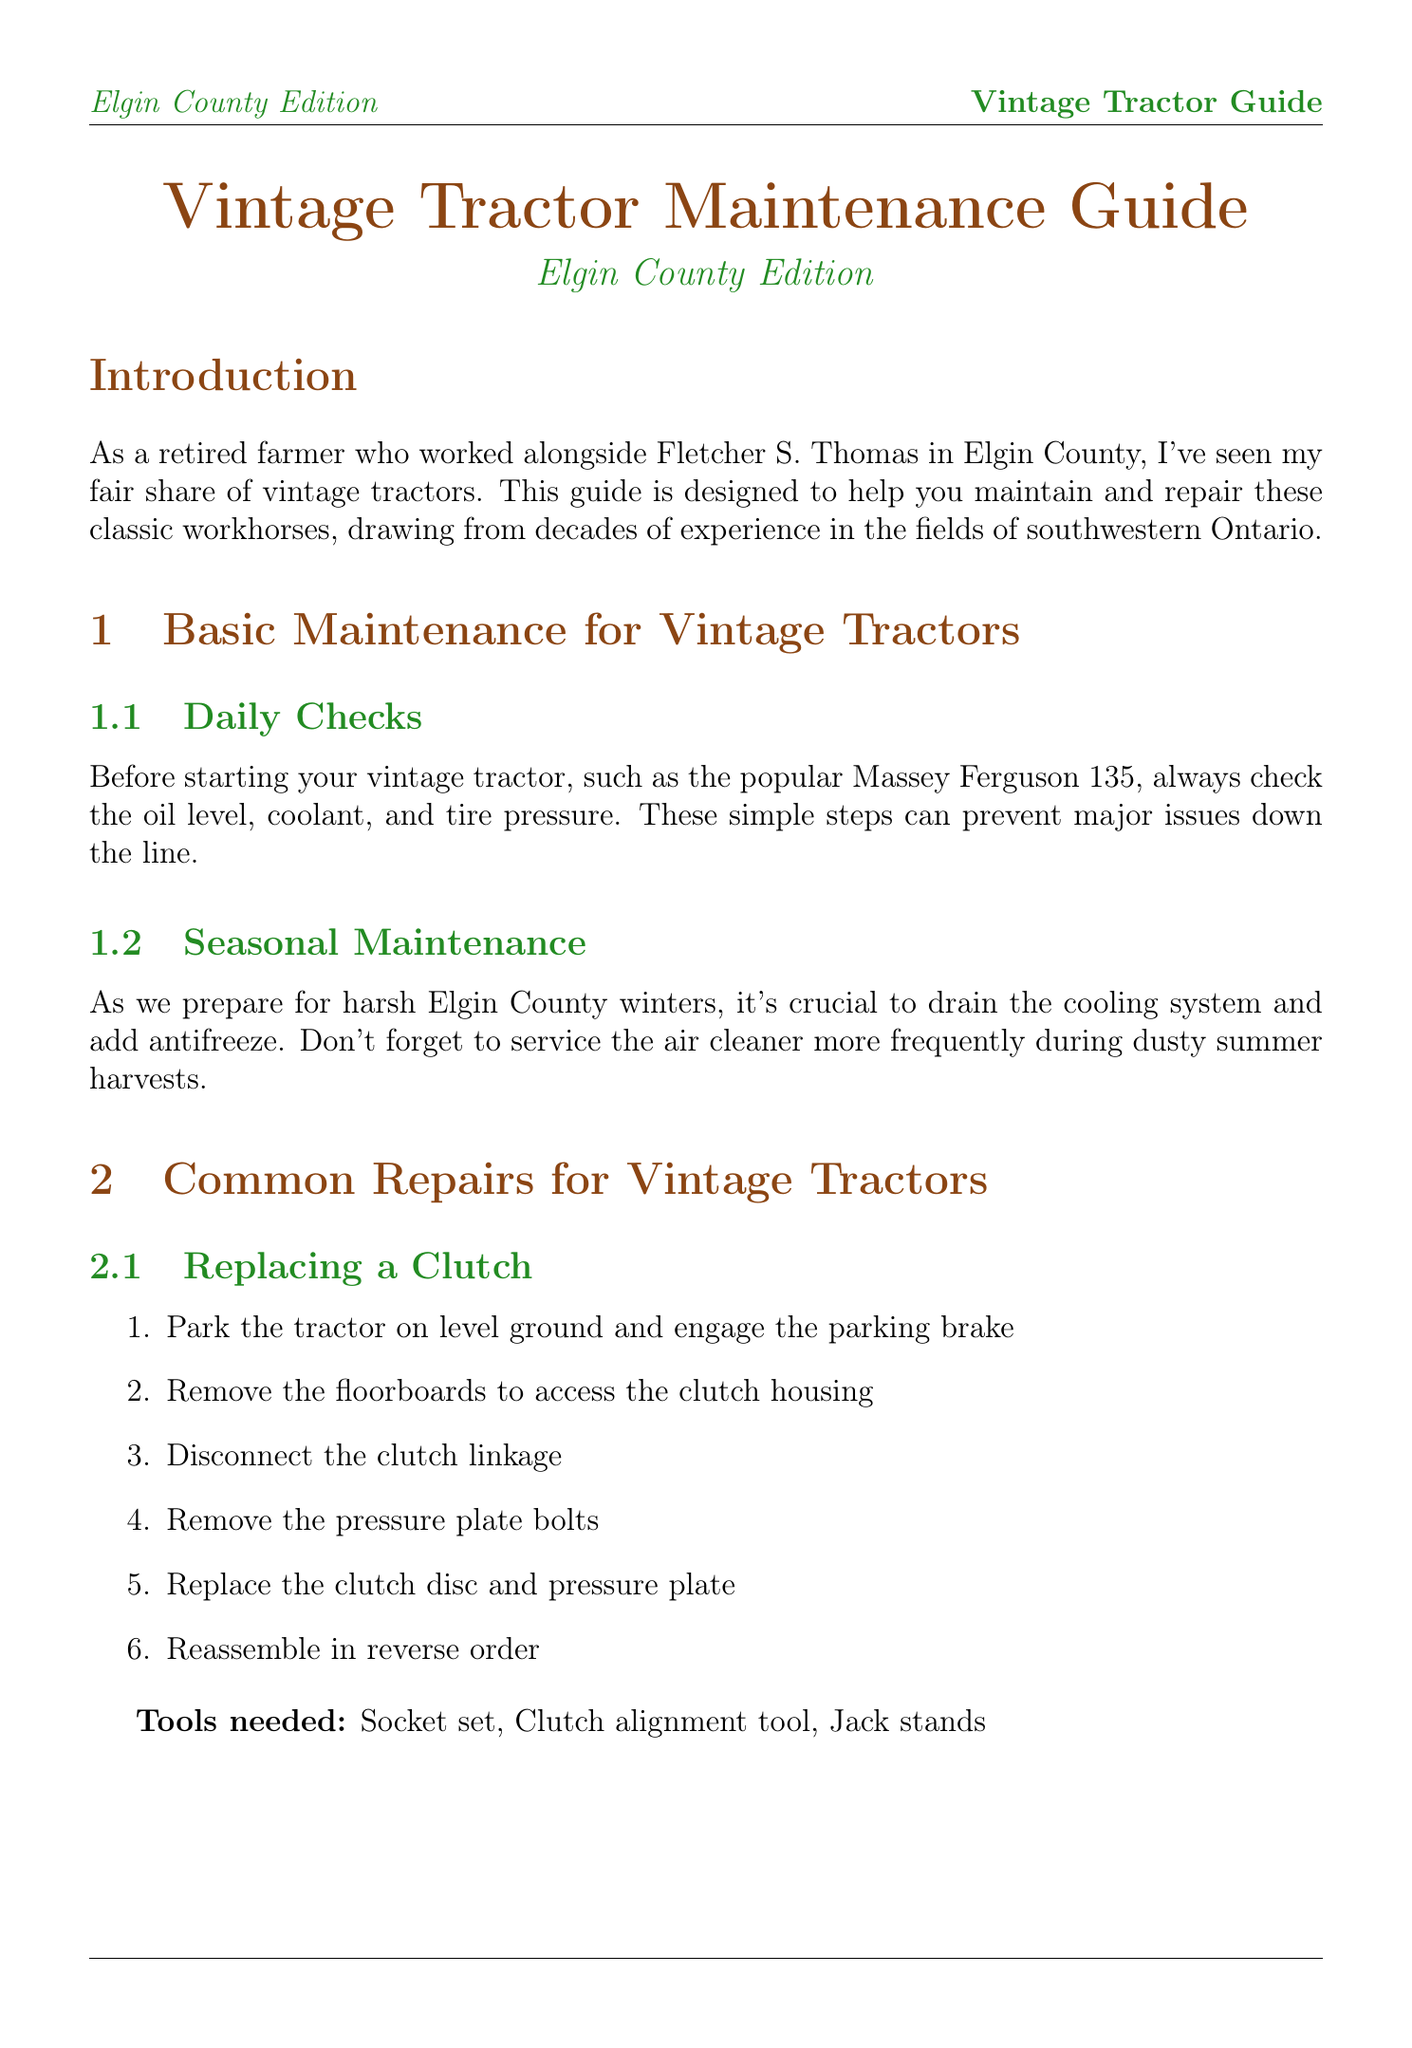What is the title of the guide? The title of the guide is provided at the beginning of the document.
Answer: Vintage Tractor Maintenance Guide: Elgin County Edition What vintage tractor model is specifically mentioned in the daily checks? The daily checks section references a popular vintage tractor model.
Answer: Massey Ferguson 135 What is a common problem if the engine won't start? The troubleshooting section outlines a few possible causes, one being a dead battery.
Answer: Dead battery How many steps are there to replace a clutch? The replacing a clutch section lists the number of steps involved in the process.
Answer: Six What tool is needed to rebuild a carburetor? The tools needed for carburetor rebuilding include various items, one of which is specified here.
Answer: Screwdrivers What must be done for seasonal maintenance in winter? The document emphasizes the importance of a specific winter maintenance step in the seasonal maintenance section.
Answer: Drain the cooling system Where should you check for hard-to-find parts? The sourcing parts section lists locations for procuring hard-to-find parts.
Answer: Elgin Farm Equipment What should be adjusted in the carburetor? The steps for rebuilding the carburetor indicate adjustments that need to be made.
Answer: Float level and idle mixture 